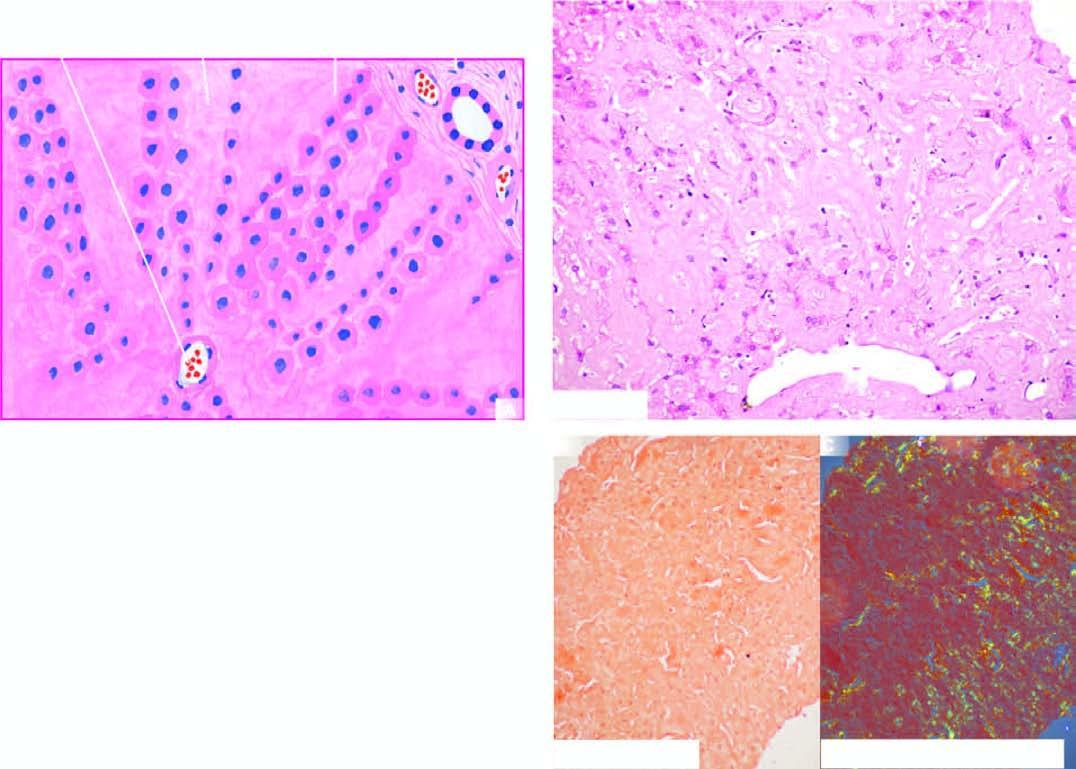what is extensive in the space of disse causing compression and pressure atrophy of hepatocytes?
Answer the question using a single word or phrase. Deposition 